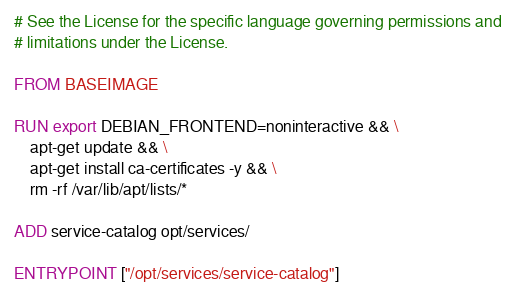<code> <loc_0><loc_0><loc_500><loc_500><_Dockerfile_># See the License for the specific language governing permissions and
# limitations under the License.

FROM BASEIMAGE

RUN export DEBIAN_FRONTEND=noninteractive && \
    apt-get update && \
    apt-get install ca-certificates -y && \
    rm -rf /var/lib/apt/lists/*

ADD service-catalog opt/services/

ENTRYPOINT ["/opt/services/service-catalog"]
</code> 